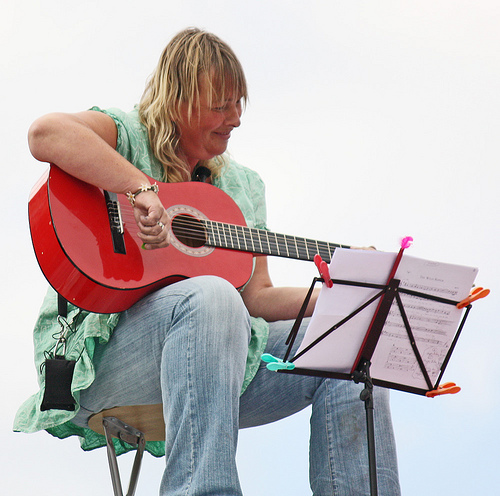<image>
Is there a guitar above the chair? No. The guitar is not positioned above the chair. The vertical arrangement shows a different relationship. 